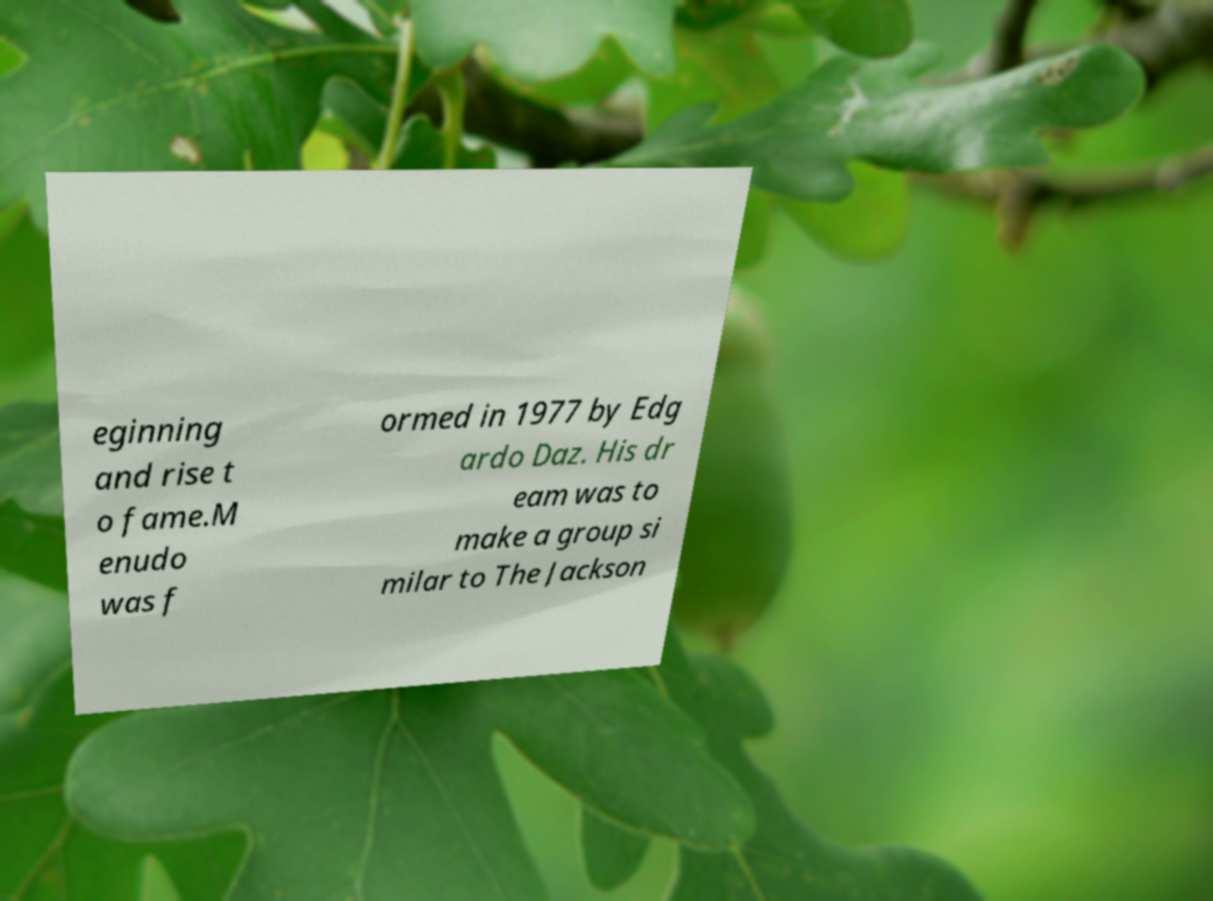Could you assist in decoding the text presented in this image and type it out clearly? eginning and rise t o fame.M enudo was f ormed in 1977 by Edg ardo Daz. His dr eam was to make a group si milar to The Jackson 